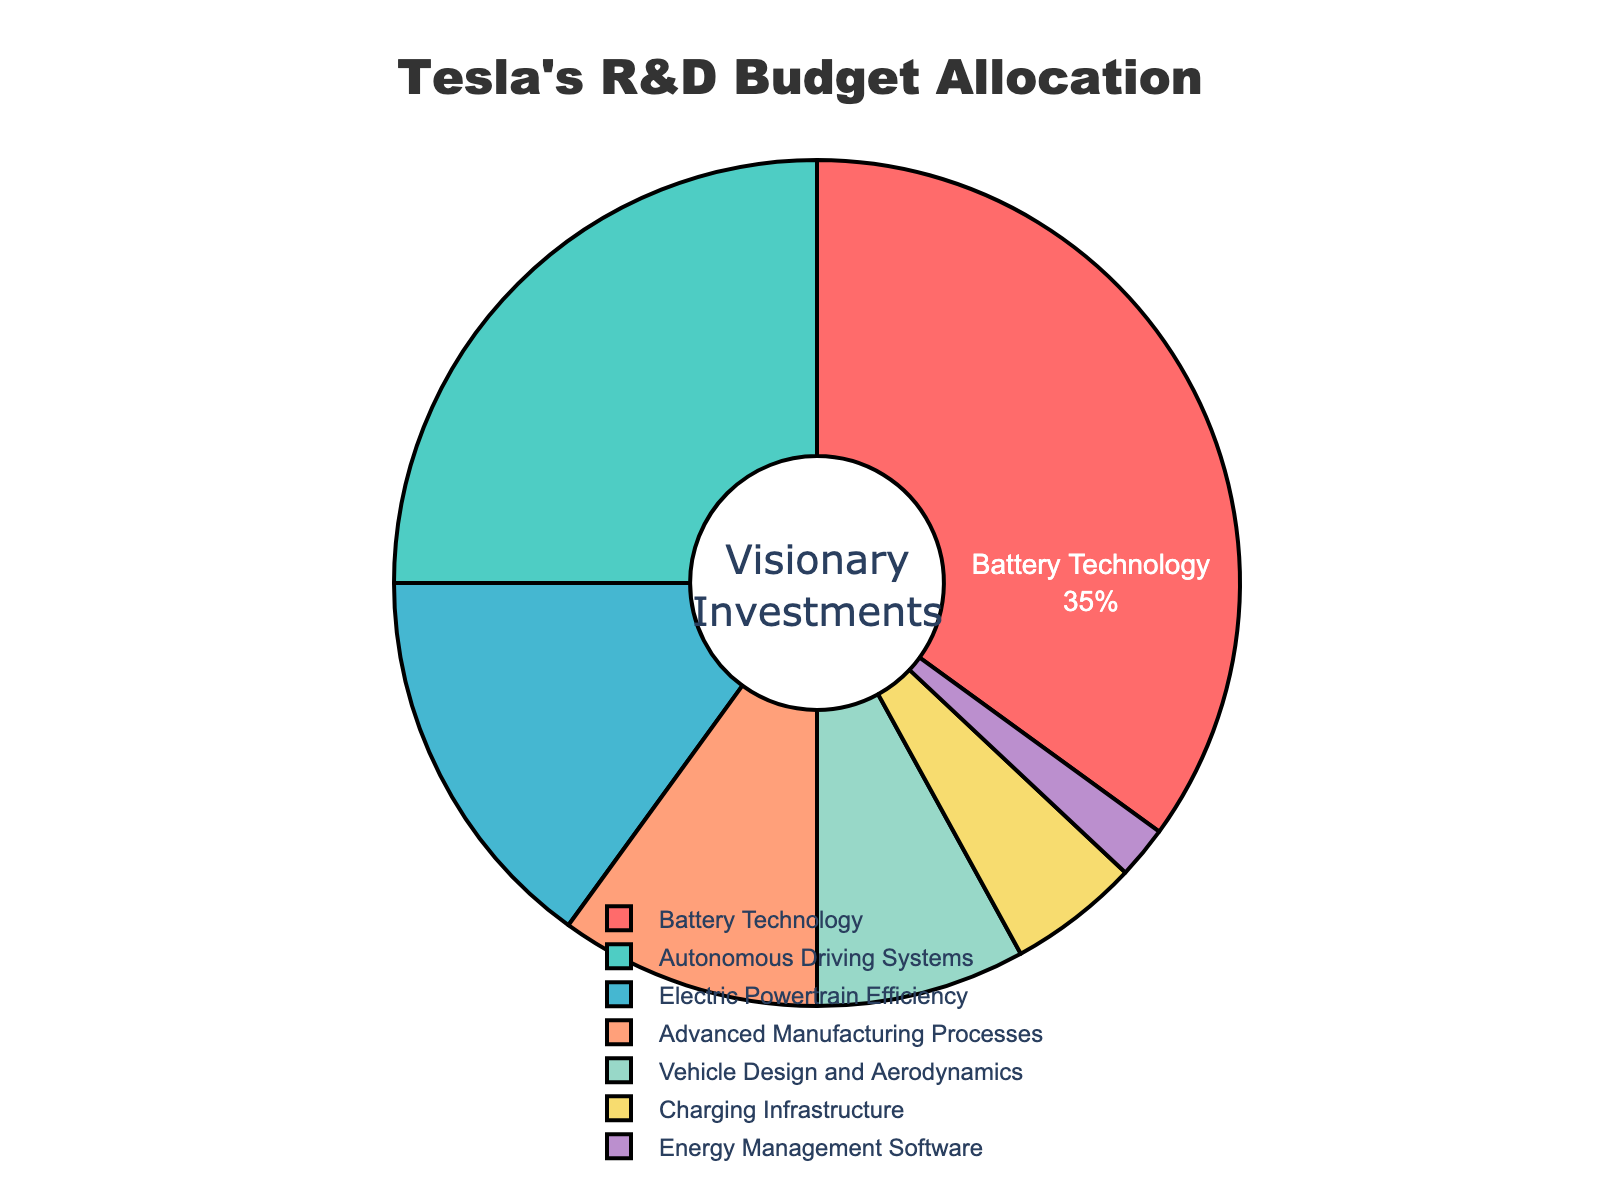What percentage of Tesla's R&D budget is allocated to Battery Technology? The figure shows that Battery Technology receives 35% of Tesla's R&D budget
Answer: 35% Which technology focus receives a higher budget allocation: Autonomous Driving Systems or Vehicle Design and Aerodynamics? According to the figure, Autonomous Driving Systems receive 25% while Vehicle Design and Aerodynamics receive 8%. Therefore, Autonomous Driving Systems have a higher budget allocation
Answer: Autonomous Driving Systems How much more budget allocation (%) does Electric Powertrain Efficiency receive compared to Charging Infrastructure? The budget allocation for Electric Powertrain Efficiency is 15% while Charging Infrastructure is 5%. The difference is 15% - 5% = 10%
Answer: 10% What is the sum of budget allocations for Advanced Manufacturing Processes and Energy Management Software? Advanced Manufacturing Processes receive 10% and Energy Management Software receives 2%. Summing these allocations gives 10% + 2% = 12%
Answer: 12% Is the budget allocation for Vehicle Design and Aerodynamics greater than the allocation for Charging Infrastructure? Vehicle Design and Aerodynamics have an 8% allocation whereas Charging Infrastructure has a 5% allocation. Therefore, 8% is greater than 5%
Answer: Yes Which segment has the smallest allocation in the pie chart? The smallest allocation as shown in the figure is for Energy Management Software at 2%
Answer: Energy Management Software What percentage of the budget is allocated to technologies other than Battery Technology? Subtracting the allocation for Battery Technology (35%) from the total 100% budget leaves 100% - 35% = 65% for other technologies
Answer: 65% Are the combined budgets for Advanced Manufacturing Processes and Vehicle Design and Aerodynamics larger than the budget for Electric Powertrain Efficiency? The combined budgets for Advanced Manufacturing Processes (10%) and Vehicle Design and Aerodynamics (8%) total 10% + 8% = 18%, which is larger than the budget for Electric Powertrain Efficiency (15%)
Answer: Yes What color represents the budget allocation for Charging Infrastructure? In the pie chart, the segment for Charging Infrastructure is shown in yellow
Answer: Yellow 